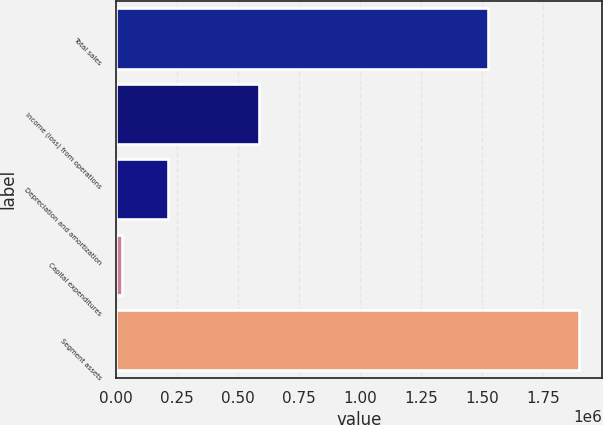<chart> <loc_0><loc_0><loc_500><loc_500><bar_chart><fcel>Total sales<fcel>Income (loss) from operations<fcel>Depreciation and amortization<fcel>Capital expenditures<fcel>Segment assets<nl><fcel>1.52458e+06<fcel>586220<fcel>212137<fcel>25095<fcel>1.89551e+06<nl></chart> 